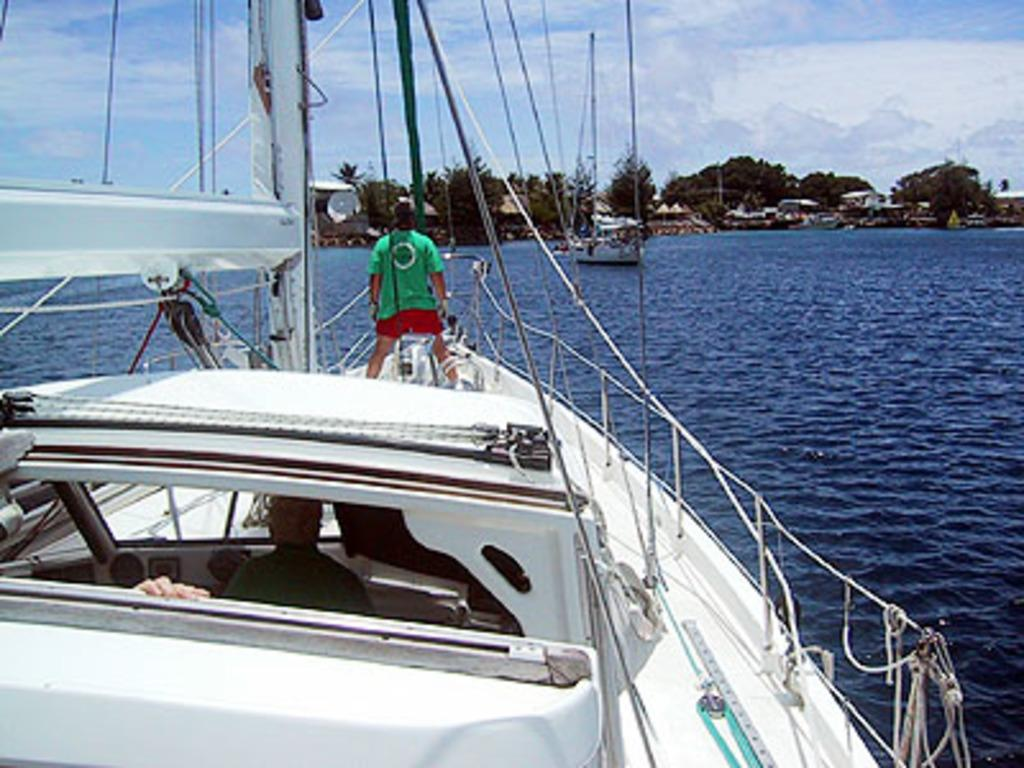What is the main subject in the center of the image? There is a boat in the center of the image. How many people are on the boat? There are two persons on the boat. What can be seen in the background of the image? The sky, clouds, trees, buildings, and water are visible in the background of the image. Can you describe the other boat in the background? There is another boat in the background of the image. What type of zipper can be seen on the boat in the image? There is no zipper present on the boat in the image. What road leads to the boat in the image? There is no road visible in the image; it features a boat on water. 